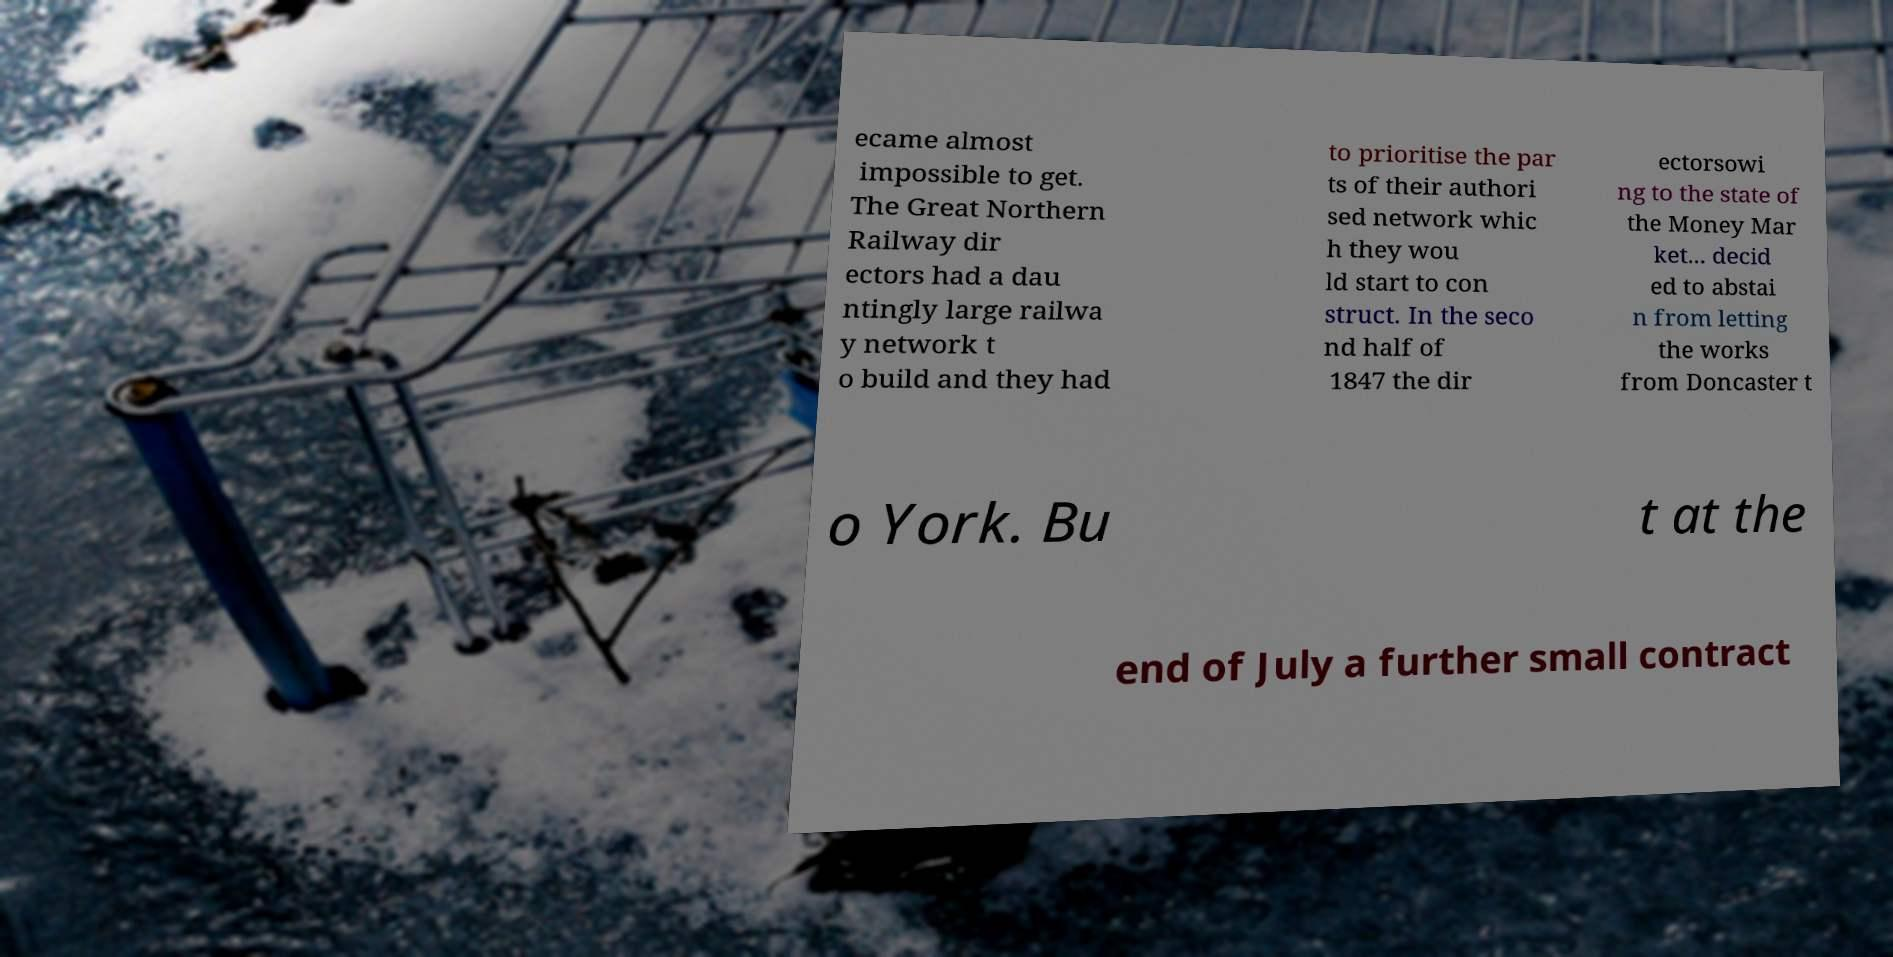I need the written content from this picture converted into text. Can you do that? ecame almost impossible to get. The Great Northern Railway dir ectors had a dau ntingly large railwa y network t o build and they had to prioritise the par ts of their authori sed network whic h they wou ld start to con struct. In the seco nd half of 1847 the dir ectorsowi ng to the state of the Money Mar ket... decid ed to abstai n from letting the works from Doncaster t o York. Bu t at the end of July a further small contract 